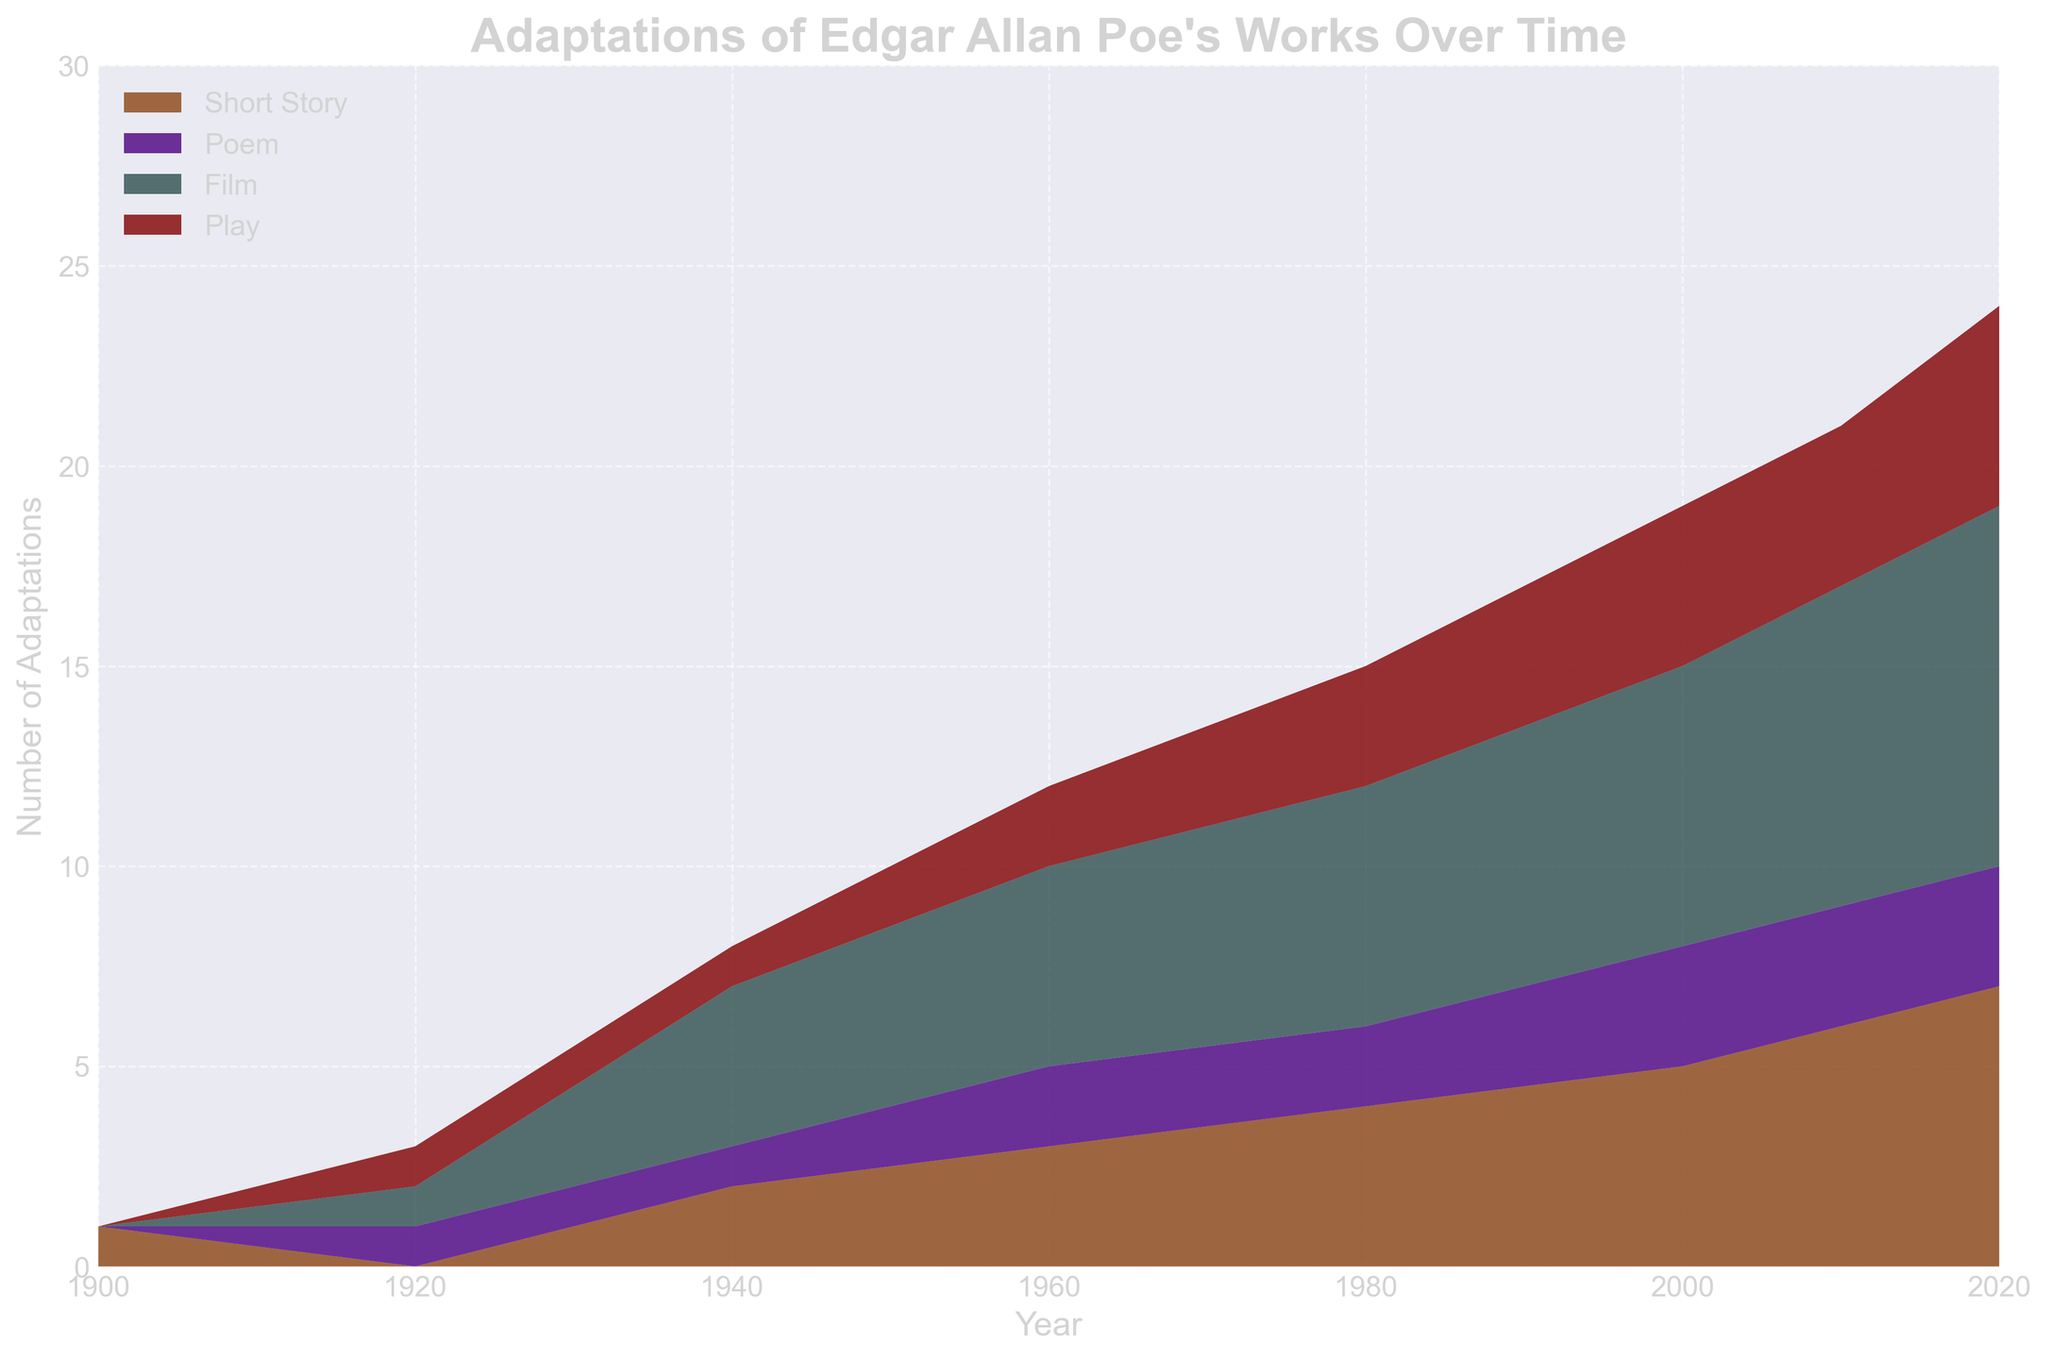What is the title of the chart? The title of the chart is typically written at the top and indicates the primary subject of the data being visualized. In this case, the title is clearly displayed at the top of the figure.
Answer: Adaptations of Edgar Allan Poe's Works Over Time Which media type had the first adaptation and in what year? To determine which media type had the first adaptation, look for the earliest year with a positive count for any media type. The figure shows values starting from the year 1900.
Answer: Short Story, 1900 How many total adaptations were there in the year 1940? Sum the number of adaptations for each media type in the year 1940. The values for this year are 2 (Short Story), 1 (Poem), 4 (Film), and 1 (Play).
Answer: 8 Between 1920 and 1960, which media type saw the highest increase in adaptations? Calculate the difference in the number of adaptations for each media type between 1920 and 1960. For Short Story: 3-0=3, Poem: 2-1=1, Film: 5-1=4, Play: 2-1=1. Identify the media type with the largest difference.
Answer: Film What is the range of adaptations for the 'Play' category from 1900 to 2020? Determine the minimum and maximum values for 'Play' across the years, then calculate the difference. The values are 0 (1900) and 5 (2020).
Answer: 0 to 5 Which year showed the highest number of total adaptations? Sum the number of adaptations for each media type in each year and identify the year with the highest total. A detailed inspection shows 2020 with values: 7 (Short Story), 3 (Poem), 9 (Film), 5 (Play) totaling 24.
Answer: 2020 How does the number of Poem adaptations in 2010 compare to 2000? Look at the number of Poem adaptations for the years 2010 and 2000. The values are 3 in both years.
Answer: Equal What trend do you observe in the number of film adaptations from 1900 to 2020? Examine the number of film adaptations over the years, from 0 in 1900 to 9 in 2020. The visual clearly shows an upward trend.
Answer: Increasing If you sum all adaptations in 2020, how many do you get? Add the number of adaptations for all media types in the year 2020: 7 (Short Story), 3 (Poem), 9 (Film), and 5 (Play).
Answer: 24 Consider the period from 2000 to 2020. Which media type consistently shows no change in its adaptation count? Analyze the values for each media type between 2000 and 2020. The Poem category remains consistent at 3 adaptations across these years.
Answer: Poem 